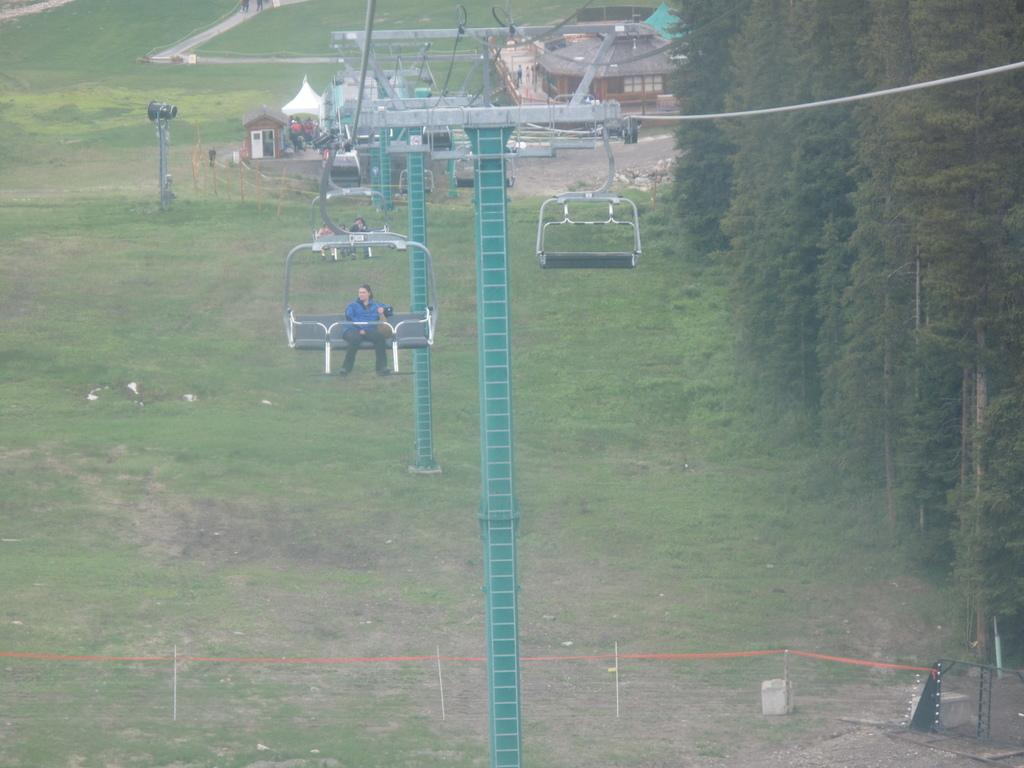What are the people in the image doing? The people are sitting in a cable car. What can be seen at the bottom of the image? There is grass and green trees at the bottom of the image. What can be seen at the top of the image? There are poles and ropes visible at the top of the image. What type of hammer is being used to coil the ropes in the image? There is no hammer or coiling of ropes present in the image. 